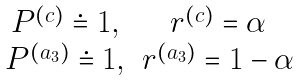Convert formula to latex. <formula><loc_0><loc_0><loc_500><loc_500>\begin{array} { c c } P ^ { ( c ) } \doteq 1 , & r ^ { ( c ) } = \alpha \\ P ^ { ( a _ { 3 } ) } \doteq 1 , & r ^ { ( a _ { 3 } ) } = 1 - \alpha \end{array}</formula> 